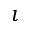Convert formula to latex. <formula><loc_0><loc_0><loc_500><loc_500>\imath</formula> 